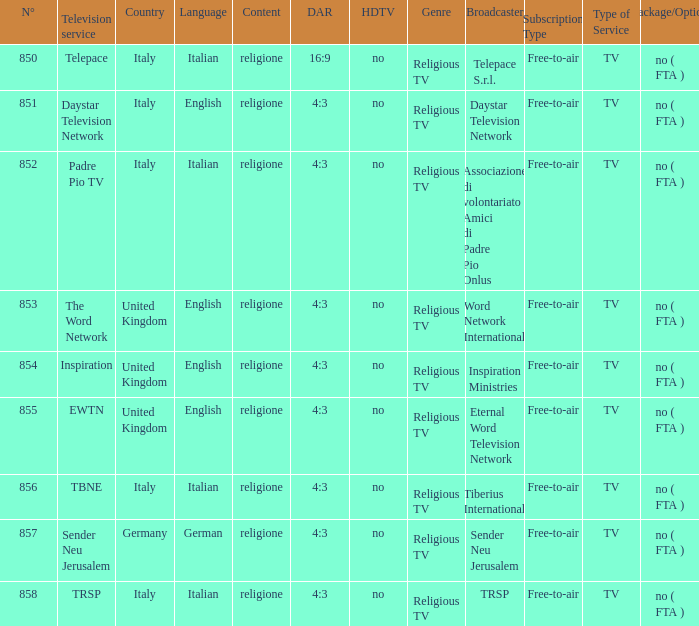How many dar are in germany? 4:3. 